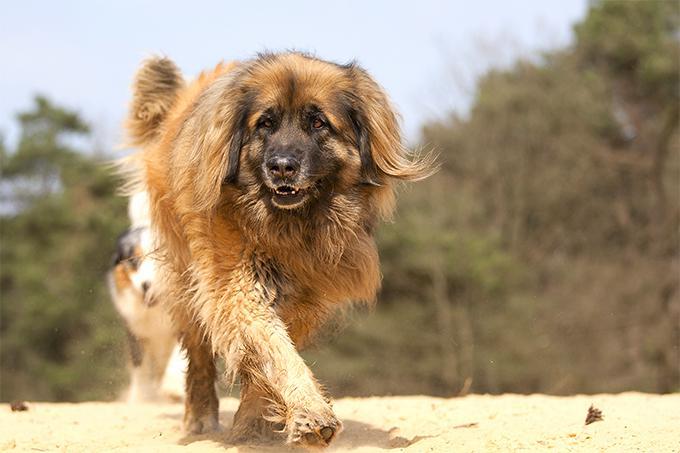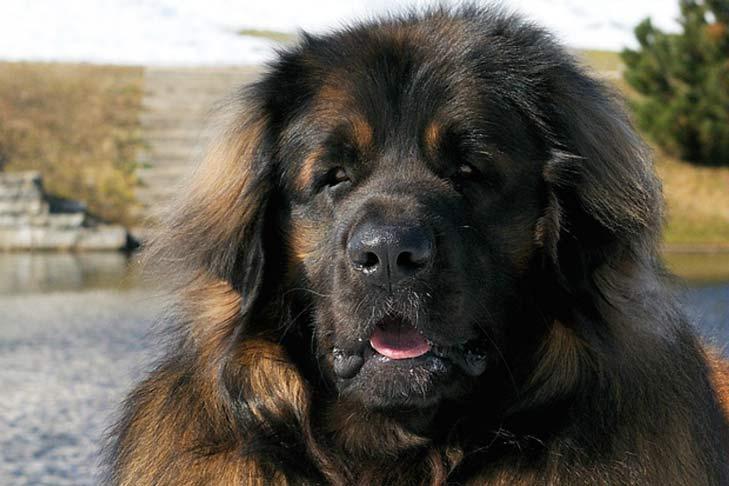The first image is the image on the left, the second image is the image on the right. For the images shown, is this caption "there is a human standing with a dog." true? Answer yes or no. No. 